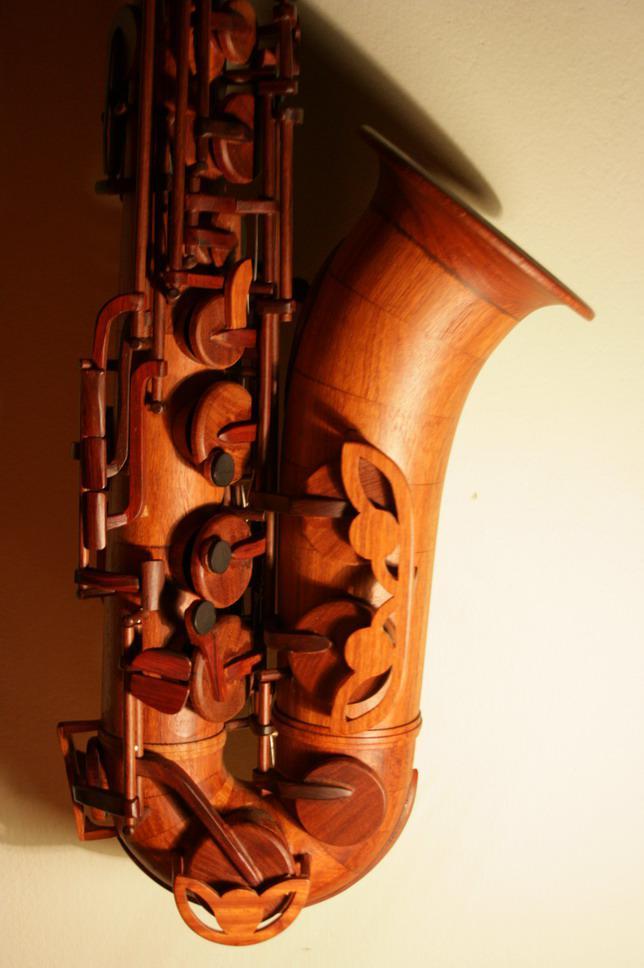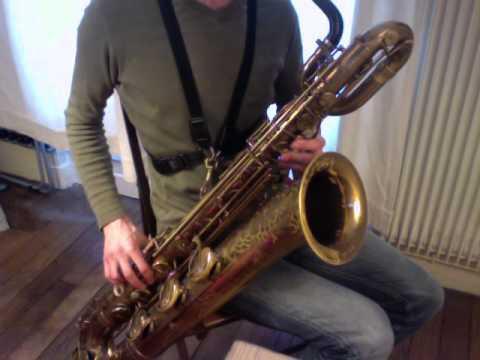The first image is the image on the left, the second image is the image on the right. Considering the images on both sides, is "In one of the images there are two saxophones placed next to each other." valid? Answer yes or no. No. 